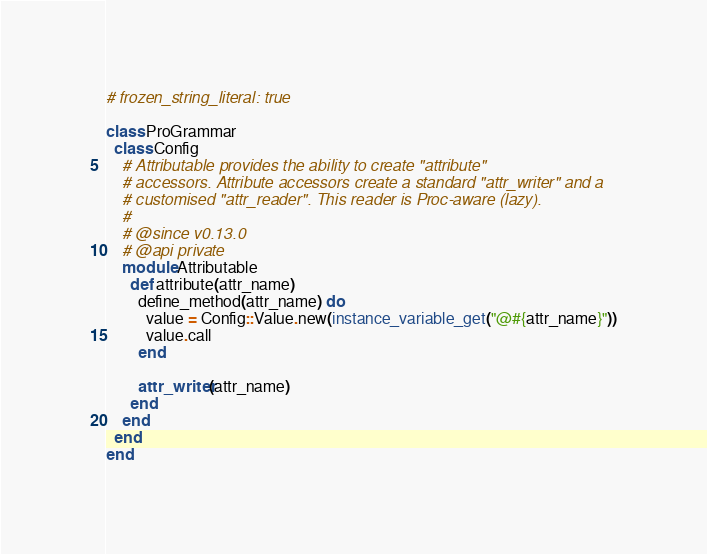Convert code to text. <code><loc_0><loc_0><loc_500><loc_500><_Ruby_># frozen_string_literal: true

class ProGrammar
  class Config
    # Attributable provides the ability to create "attribute"
    # accessors. Attribute accessors create a standard "attr_writer" and a
    # customised "attr_reader". This reader is Proc-aware (lazy).
    #
    # @since v0.13.0
    # @api private
    module Attributable
      def attribute(attr_name)
        define_method(attr_name) do
          value = Config::Value.new(instance_variable_get("@#{attr_name}"))
          value.call
        end

        attr_writer(attr_name)
      end
    end
  end
end
</code> 